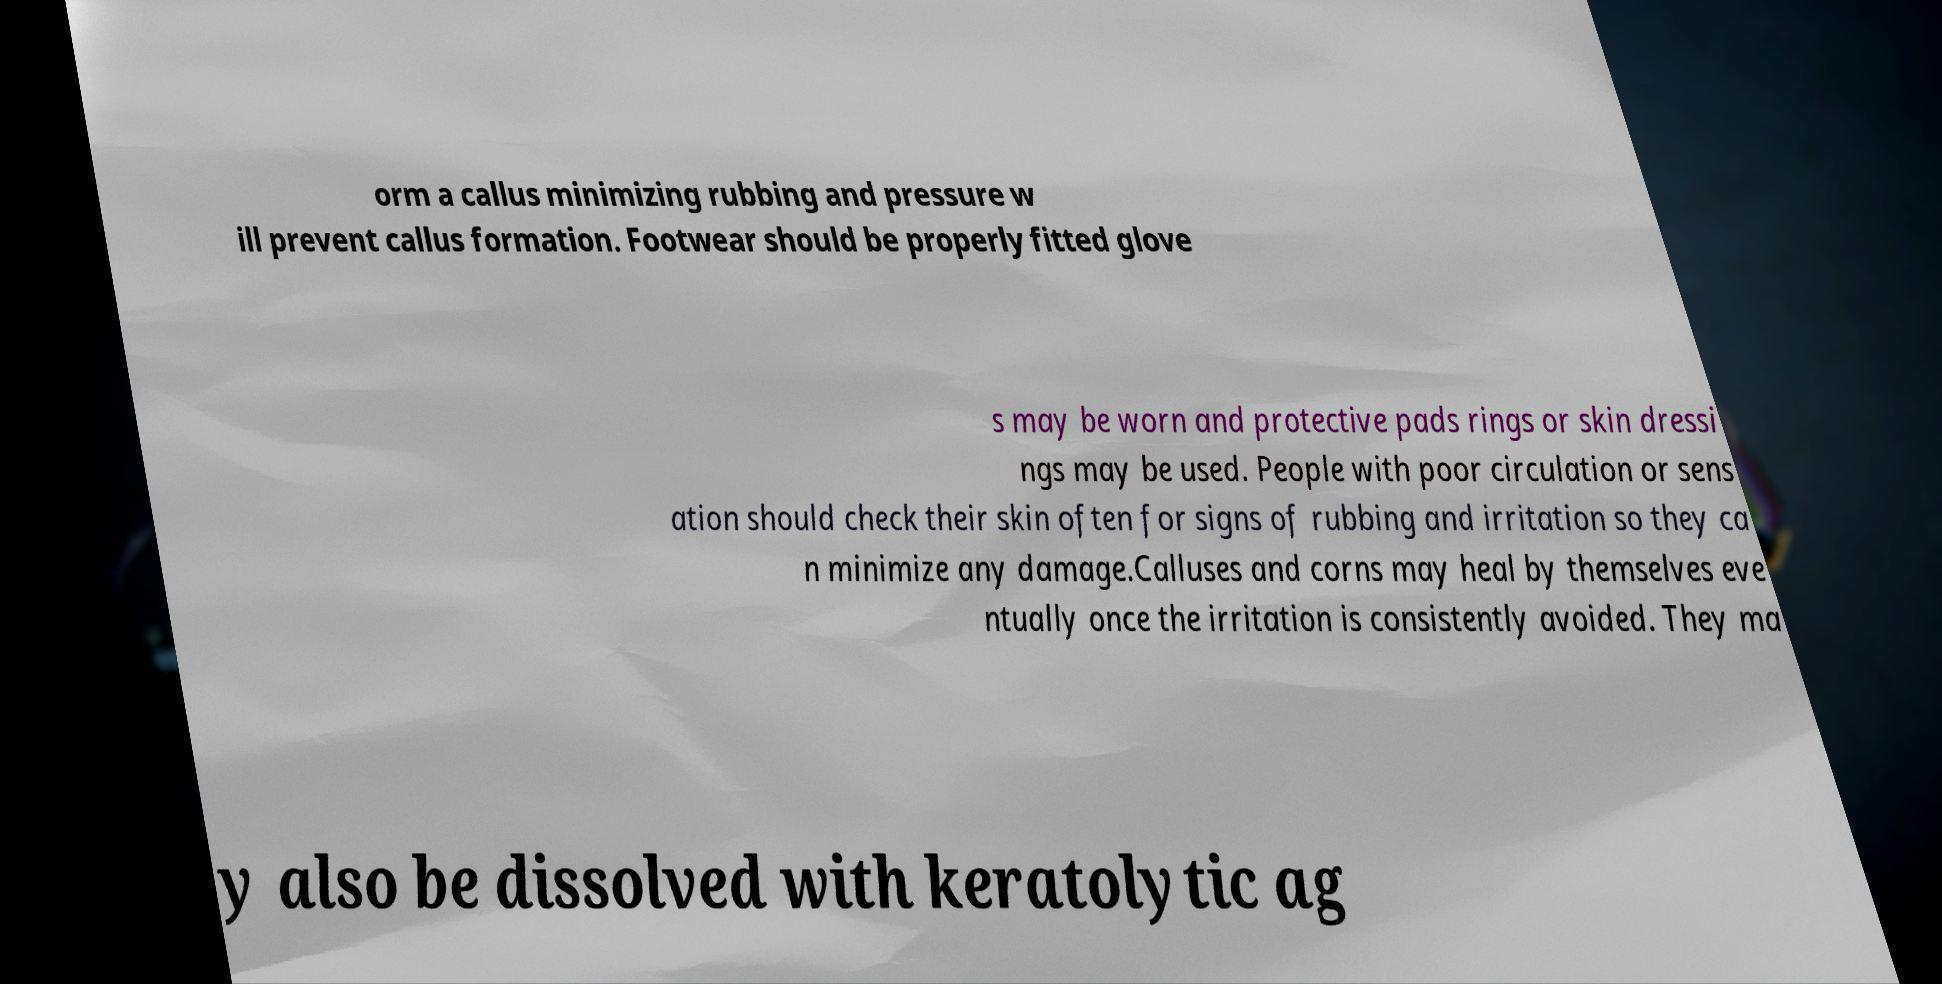Can you accurately transcribe the text from the provided image for me? orm a callus minimizing rubbing and pressure w ill prevent callus formation. Footwear should be properly fitted glove s may be worn and protective pads rings or skin dressi ngs may be used. People with poor circulation or sens ation should check their skin often for signs of rubbing and irritation so they ca n minimize any damage.Calluses and corns may heal by themselves eve ntually once the irritation is consistently avoided. They ma y also be dissolved with keratolytic ag 